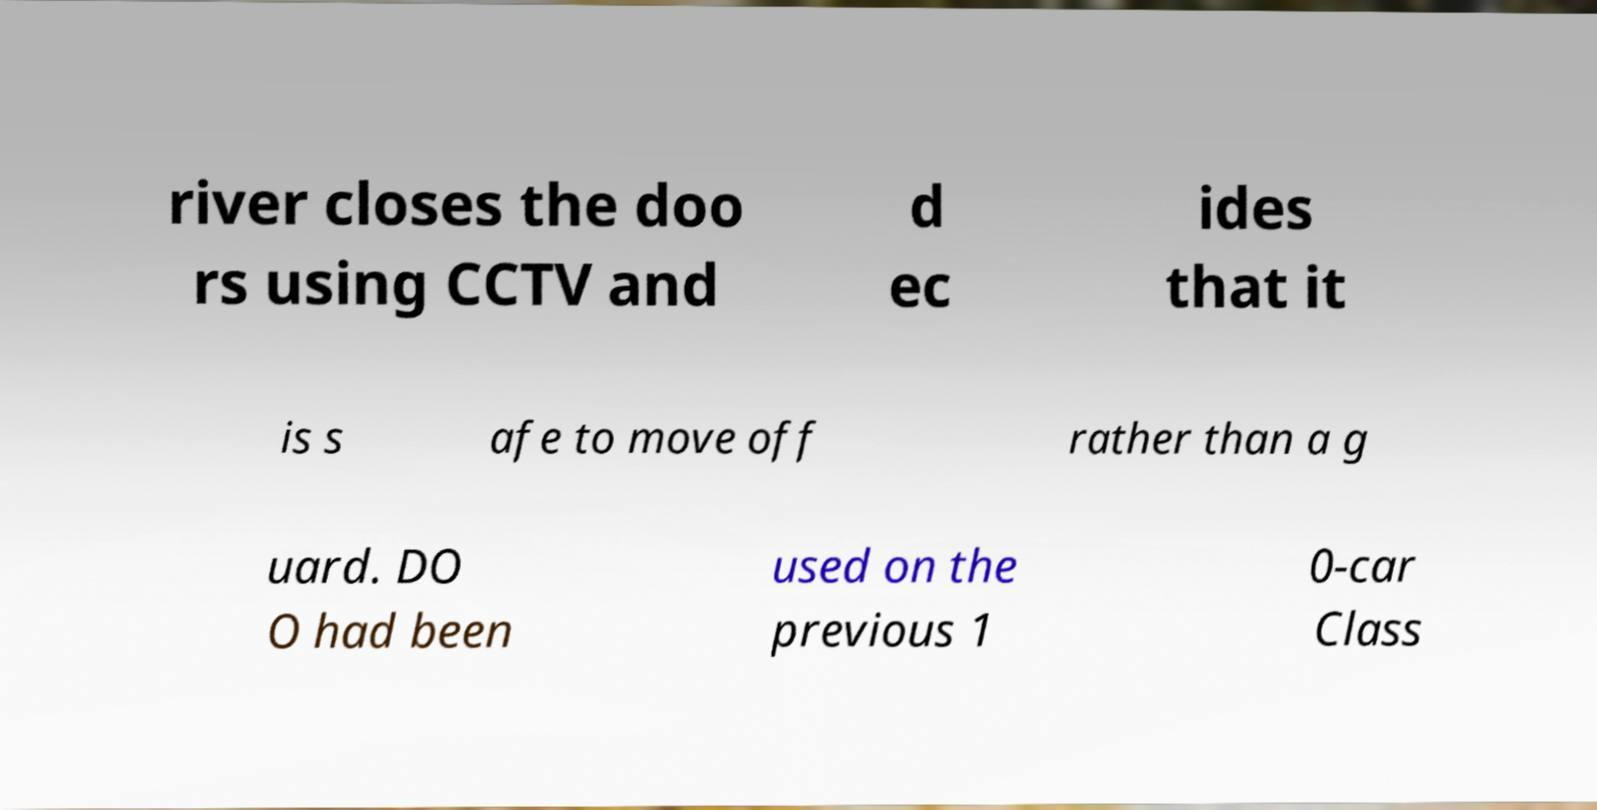For documentation purposes, I need the text within this image transcribed. Could you provide that? river closes the doo rs using CCTV and d ec ides that it is s afe to move off rather than a g uard. DO O had been used on the previous 1 0-car Class 